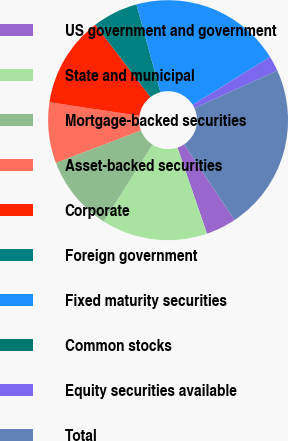Convert chart. <chart><loc_0><loc_0><loc_500><loc_500><pie_chart><fcel>US government and government<fcel>State and municipal<fcel>Mortgage-backed securities<fcel>Asset-backed securities<fcel>Corporate<fcel>Foreign government<fcel>Fixed maturity securities<fcel>Common stocks<fcel>Equity securities available<fcel>Total<nl><fcel>4.09%<fcel>14.28%<fcel>10.21%<fcel>8.17%<fcel>12.25%<fcel>6.13%<fcel>20.4%<fcel>0.01%<fcel>2.05%<fcel>22.44%<nl></chart> 